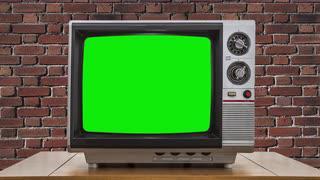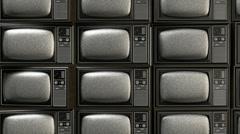The first image is the image on the left, the second image is the image on the right. Evaluate the accuracy of this statement regarding the images: "The left image contains at least one old-fashioned TV with controls to the right of a slightly rounded square screen, which is glowing green.". Is it true? Answer yes or no. Yes. The first image is the image on the left, the second image is the image on the right. Examine the images to the left and right. Is the description "At least one television's display is bright green." accurate? Answer yes or no. Yes. 